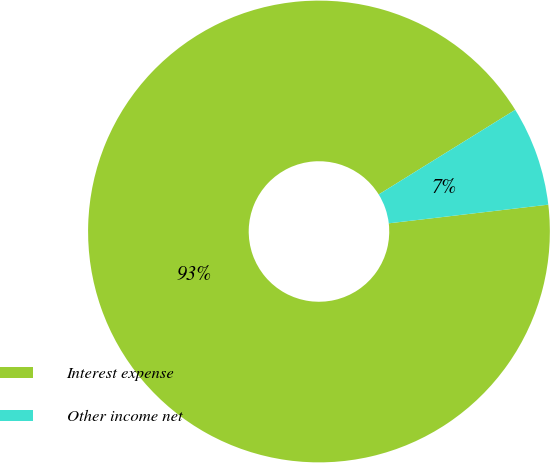Convert chart. <chart><loc_0><loc_0><loc_500><loc_500><pie_chart><fcel>Interest expense<fcel>Other income net<nl><fcel>93.02%<fcel>6.98%<nl></chart> 